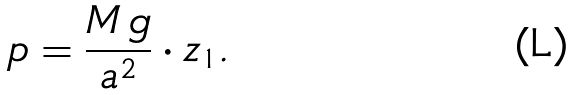Convert formula to latex. <formula><loc_0><loc_0><loc_500><loc_500>p = \frac { M \, g } { a ^ { 2 } } \cdot z _ { 1 } .</formula> 